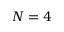Convert formula to latex. <formula><loc_0><loc_0><loc_500><loc_500>N = 4</formula> 